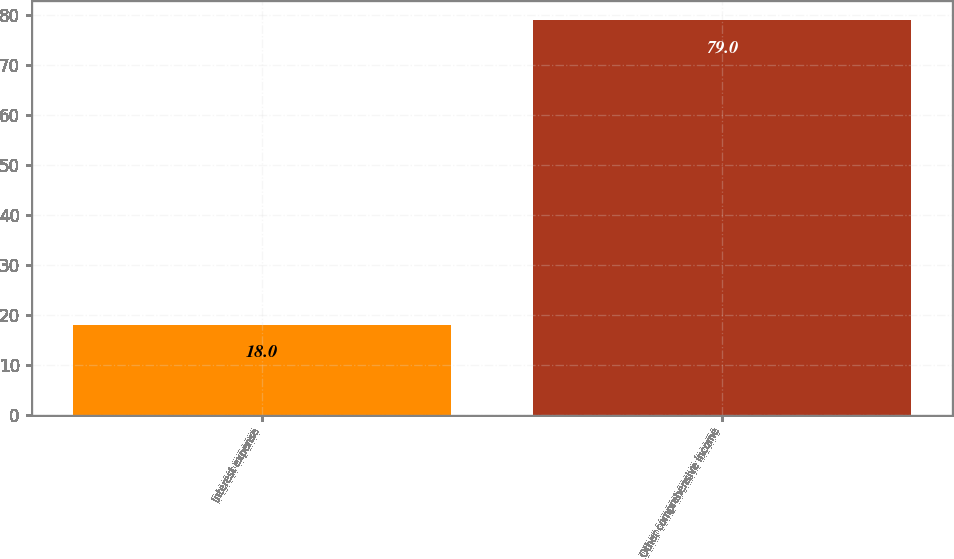<chart> <loc_0><loc_0><loc_500><loc_500><bar_chart><fcel>Interest expense<fcel>Other comprehensive income<nl><fcel>18<fcel>79<nl></chart> 